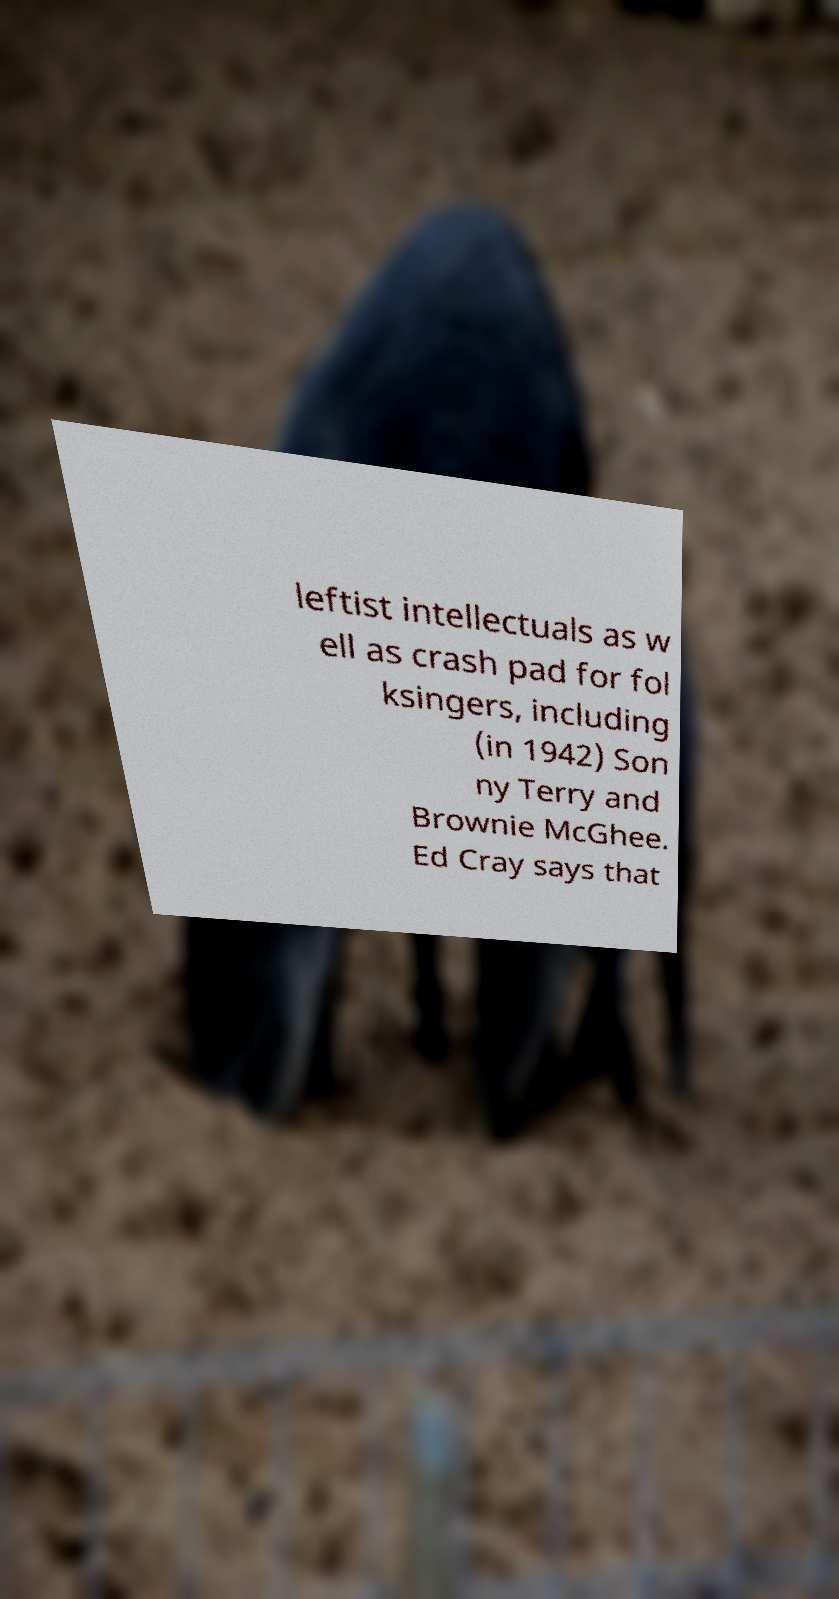Please identify and transcribe the text found in this image. leftist intellectuals as w ell as crash pad for fol ksingers, including (in 1942) Son ny Terry and Brownie McGhee. Ed Cray says that 